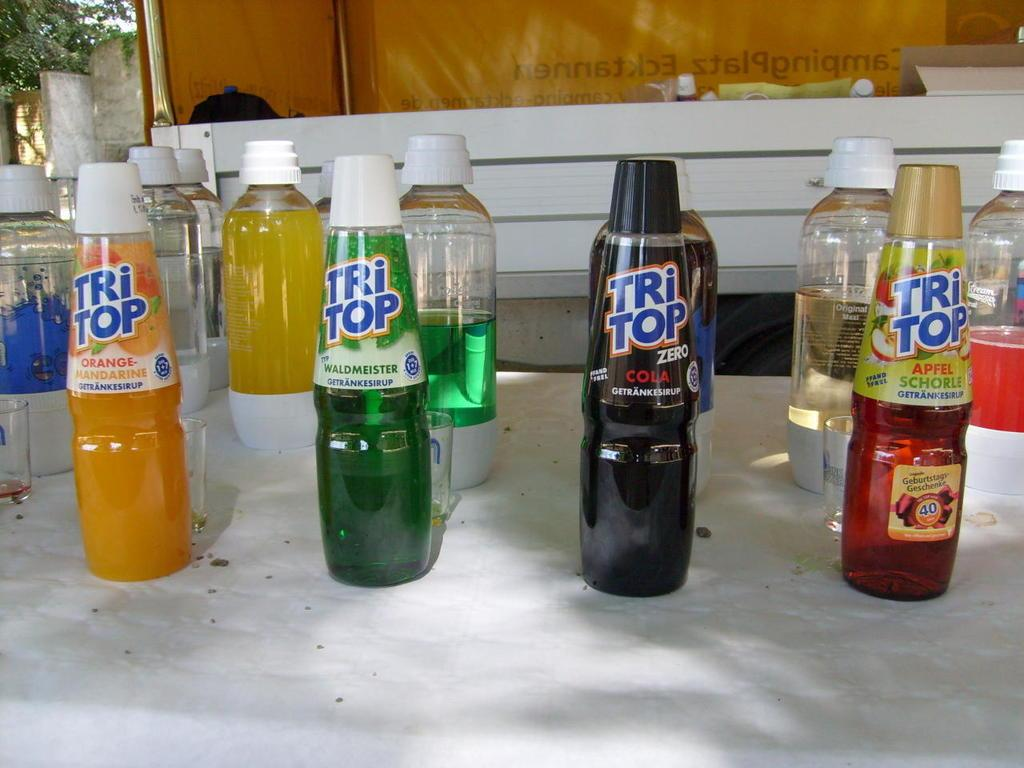<image>
Describe the image concisely. Four bottles of various flavors of Tri Top displayed on a counter. 